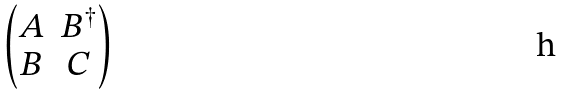<formula> <loc_0><loc_0><loc_500><loc_500>\begin{pmatrix} A & B ^ { \dagger } \\ B & C \end{pmatrix}</formula> 